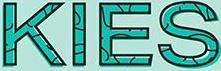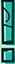Read the text content from these images in order, separated by a semicolon. KIES; ! 